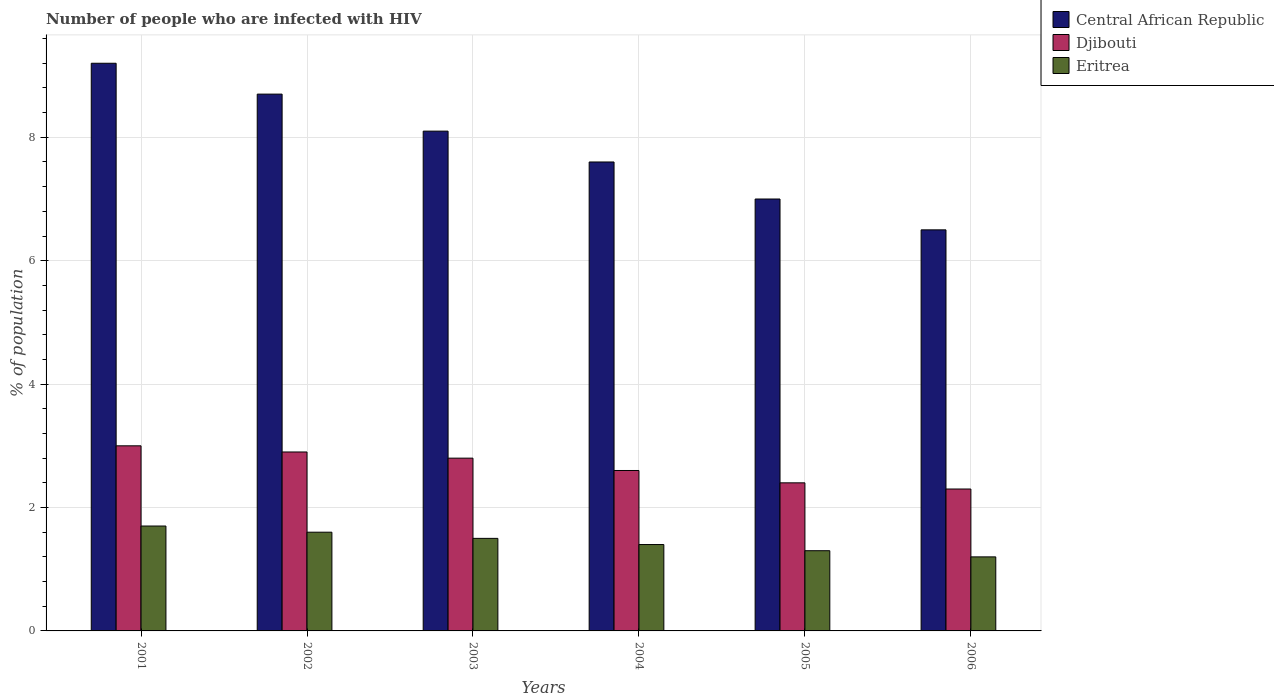How many different coloured bars are there?
Ensure brevity in your answer.  3. How many groups of bars are there?
Your response must be concise. 6. Are the number of bars on each tick of the X-axis equal?
Provide a short and direct response. Yes. How many bars are there on the 6th tick from the right?
Offer a very short reply. 3. What is the label of the 3rd group of bars from the left?
Your response must be concise. 2003. In how many cases, is the number of bars for a given year not equal to the number of legend labels?
Give a very brief answer. 0. In which year was the percentage of HIV infected population in in Central African Republic minimum?
Keep it short and to the point. 2006. What is the total percentage of HIV infected population in in Central African Republic in the graph?
Keep it short and to the point. 47.1. What is the difference between the percentage of HIV infected population in in Eritrea in 2002 and that in 2006?
Offer a very short reply. 0.4. What is the difference between the percentage of HIV infected population in in Central African Republic in 2006 and the percentage of HIV infected population in in Eritrea in 2004?
Your answer should be very brief. 5.1. What is the average percentage of HIV infected population in in Eritrea per year?
Give a very brief answer. 1.45. In the year 2003, what is the difference between the percentage of HIV infected population in in Eritrea and percentage of HIV infected population in in Djibouti?
Give a very brief answer. -1.3. In how many years, is the percentage of HIV infected population in in Eritrea greater than 8.8 %?
Make the answer very short. 0. What is the ratio of the percentage of HIV infected population in in Djibouti in 2001 to that in 2006?
Your answer should be compact. 1.3. What is the difference between the highest and the second highest percentage of HIV infected population in in Djibouti?
Your answer should be compact. 0.1. What is the difference between the highest and the lowest percentage of HIV infected population in in Djibouti?
Offer a terse response. 0.7. Is the sum of the percentage of HIV infected population in in Central African Republic in 2003 and 2005 greater than the maximum percentage of HIV infected population in in Djibouti across all years?
Provide a short and direct response. Yes. What does the 1st bar from the left in 2001 represents?
Provide a succinct answer. Central African Republic. What does the 2nd bar from the right in 2002 represents?
Keep it short and to the point. Djibouti. How many bars are there?
Offer a very short reply. 18. Are all the bars in the graph horizontal?
Make the answer very short. No. What is the difference between two consecutive major ticks on the Y-axis?
Offer a terse response. 2. Does the graph contain any zero values?
Ensure brevity in your answer.  No. How are the legend labels stacked?
Offer a terse response. Vertical. What is the title of the graph?
Give a very brief answer. Number of people who are infected with HIV. What is the label or title of the X-axis?
Offer a very short reply. Years. What is the label or title of the Y-axis?
Provide a succinct answer. % of population. What is the % of population of Djibouti in 2001?
Offer a terse response. 3. What is the % of population in Eritrea in 2001?
Ensure brevity in your answer.  1.7. What is the % of population in Eritrea in 2002?
Offer a terse response. 1.6. What is the % of population of Central African Republic in 2003?
Provide a succinct answer. 8.1. What is the % of population of Eritrea in 2003?
Make the answer very short. 1.5. What is the % of population of Central African Republic in 2004?
Ensure brevity in your answer.  7.6. Across all years, what is the maximum % of population of Central African Republic?
Your response must be concise. 9.2. Across all years, what is the maximum % of population in Eritrea?
Your response must be concise. 1.7. Across all years, what is the minimum % of population of Djibouti?
Your response must be concise. 2.3. Across all years, what is the minimum % of population of Eritrea?
Your response must be concise. 1.2. What is the total % of population of Central African Republic in the graph?
Ensure brevity in your answer.  47.1. What is the total % of population in Eritrea in the graph?
Provide a succinct answer. 8.7. What is the difference between the % of population of Central African Republic in 2001 and that in 2002?
Your answer should be compact. 0.5. What is the difference between the % of population in Djibouti in 2001 and that in 2002?
Your answer should be very brief. 0.1. What is the difference between the % of population in Eritrea in 2001 and that in 2002?
Your answer should be compact. 0.1. What is the difference between the % of population in Central African Republic in 2001 and that in 2003?
Provide a succinct answer. 1.1. What is the difference between the % of population in Djibouti in 2001 and that in 2003?
Make the answer very short. 0.2. What is the difference between the % of population in Djibouti in 2001 and that in 2004?
Provide a short and direct response. 0.4. What is the difference between the % of population of Eritrea in 2001 and that in 2004?
Your answer should be compact. 0.3. What is the difference between the % of population in Djibouti in 2001 and that in 2005?
Provide a short and direct response. 0.6. What is the difference between the % of population in Central African Republic in 2001 and that in 2006?
Provide a short and direct response. 2.7. What is the difference between the % of population of Djibouti in 2001 and that in 2006?
Provide a short and direct response. 0.7. What is the difference between the % of population of Djibouti in 2002 and that in 2003?
Keep it short and to the point. 0.1. What is the difference between the % of population of Central African Republic in 2002 and that in 2004?
Provide a short and direct response. 1.1. What is the difference between the % of population in Djibouti in 2002 and that in 2004?
Keep it short and to the point. 0.3. What is the difference between the % of population in Eritrea in 2002 and that in 2004?
Provide a succinct answer. 0.2. What is the difference between the % of population in Djibouti in 2003 and that in 2004?
Make the answer very short. 0.2. What is the difference between the % of population in Eritrea in 2003 and that in 2004?
Give a very brief answer. 0.1. What is the difference between the % of population in Central African Republic in 2003 and that in 2005?
Offer a very short reply. 1.1. What is the difference between the % of population in Djibouti in 2003 and that in 2005?
Keep it short and to the point. 0.4. What is the difference between the % of population in Central African Republic in 2003 and that in 2006?
Provide a short and direct response. 1.6. What is the difference between the % of population in Eritrea in 2003 and that in 2006?
Keep it short and to the point. 0.3. What is the difference between the % of population of Central African Republic in 2004 and that in 2005?
Give a very brief answer. 0.6. What is the difference between the % of population in Djibouti in 2004 and that in 2005?
Ensure brevity in your answer.  0.2. What is the difference between the % of population in Djibouti in 2004 and that in 2006?
Your answer should be compact. 0.3. What is the difference between the % of population of Central African Republic in 2001 and the % of population of Djibouti in 2002?
Your answer should be very brief. 6.3. What is the difference between the % of population in Central African Republic in 2001 and the % of population in Djibouti in 2003?
Your answer should be very brief. 6.4. What is the difference between the % of population of Central African Republic in 2001 and the % of population of Eritrea in 2003?
Keep it short and to the point. 7.7. What is the difference between the % of population of Djibouti in 2001 and the % of population of Eritrea in 2003?
Give a very brief answer. 1.5. What is the difference between the % of population of Central African Republic in 2001 and the % of population of Djibouti in 2004?
Offer a terse response. 6.6. What is the difference between the % of population in Djibouti in 2001 and the % of population in Eritrea in 2004?
Your answer should be compact. 1.6. What is the difference between the % of population of Djibouti in 2001 and the % of population of Eritrea in 2005?
Offer a terse response. 1.7. What is the difference between the % of population in Central African Republic in 2001 and the % of population in Djibouti in 2006?
Your answer should be compact. 6.9. What is the difference between the % of population in Central African Republic in 2002 and the % of population in Eritrea in 2004?
Your response must be concise. 7.3. What is the difference between the % of population in Djibouti in 2002 and the % of population in Eritrea in 2004?
Offer a very short reply. 1.5. What is the difference between the % of population of Central African Republic in 2002 and the % of population of Djibouti in 2006?
Keep it short and to the point. 6.4. What is the difference between the % of population in Central African Republic in 2002 and the % of population in Eritrea in 2006?
Keep it short and to the point. 7.5. What is the difference between the % of population in Djibouti in 2003 and the % of population in Eritrea in 2004?
Keep it short and to the point. 1.4. What is the difference between the % of population of Djibouti in 2003 and the % of population of Eritrea in 2005?
Provide a short and direct response. 1.5. What is the difference between the % of population in Central African Republic in 2003 and the % of population in Djibouti in 2006?
Your answer should be compact. 5.8. What is the difference between the % of population of Central African Republic in 2004 and the % of population of Djibouti in 2005?
Keep it short and to the point. 5.2. What is the difference between the % of population of Central African Republic in 2004 and the % of population of Eritrea in 2005?
Give a very brief answer. 6.3. What is the difference between the % of population of Djibouti in 2004 and the % of population of Eritrea in 2005?
Offer a terse response. 1.3. What is the difference between the % of population of Central African Republic in 2004 and the % of population of Eritrea in 2006?
Provide a short and direct response. 6.4. What is the difference between the % of population in Djibouti in 2004 and the % of population in Eritrea in 2006?
Offer a terse response. 1.4. What is the difference between the % of population of Central African Republic in 2005 and the % of population of Djibouti in 2006?
Your response must be concise. 4.7. What is the difference between the % of population in Djibouti in 2005 and the % of population in Eritrea in 2006?
Provide a short and direct response. 1.2. What is the average % of population in Central African Republic per year?
Your response must be concise. 7.85. What is the average % of population in Djibouti per year?
Your answer should be compact. 2.67. What is the average % of population in Eritrea per year?
Ensure brevity in your answer.  1.45. In the year 2001, what is the difference between the % of population in Central African Republic and % of population in Eritrea?
Give a very brief answer. 7.5. In the year 2002, what is the difference between the % of population in Central African Republic and % of population in Djibouti?
Make the answer very short. 5.8. In the year 2002, what is the difference between the % of population of Central African Republic and % of population of Eritrea?
Provide a succinct answer. 7.1. In the year 2002, what is the difference between the % of population of Djibouti and % of population of Eritrea?
Make the answer very short. 1.3. In the year 2003, what is the difference between the % of population in Central African Republic and % of population in Djibouti?
Your answer should be compact. 5.3. In the year 2003, what is the difference between the % of population in Central African Republic and % of population in Eritrea?
Provide a succinct answer. 6.6. In the year 2004, what is the difference between the % of population in Central African Republic and % of population in Djibouti?
Offer a terse response. 5. In the year 2005, what is the difference between the % of population of Djibouti and % of population of Eritrea?
Offer a very short reply. 1.1. In the year 2006, what is the difference between the % of population in Central African Republic and % of population in Djibouti?
Make the answer very short. 4.2. What is the ratio of the % of population in Central African Republic in 2001 to that in 2002?
Offer a terse response. 1.06. What is the ratio of the % of population of Djibouti in 2001 to that in 2002?
Offer a terse response. 1.03. What is the ratio of the % of population in Central African Republic in 2001 to that in 2003?
Provide a short and direct response. 1.14. What is the ratio of the % of population in Djibouti in 2001 to that in 2003?
Provide a succinct answer. 1.07. What is the ratio of the % of population of Eritrea in 2001 to that in 2003?
Provide a succinct answer. 1.13. What is the ratio of the % of population of Central African Republic in 2001 to that in 2004?
Keep it short and to the point. 1.21. What is the ratio of the % of population in Djibouti in 2001 to that in 2004?
Give a very brief answer. 1.15. What is the ratio of the % of population in Eritrea in 2001 to that in 2004?
Give a very brief answer. 1.21. What is the ratio of the % of population of Central African Republic in 2001 to that in 2005?
Keep it short and to the point. 1.31. What is the ratio of the % of population in Djibouti in 2001 to that in 2005?
Your response must be concise. 1.25. What is the ratio of the % of population in Eritrea in 2001 to that in 2005?
Provide a short and direct response. 1.31. What is the ratio of the % of population in Central African Republic in 2001 to that in 2006?
Keep it short and to the point. 1.42. What is the ratio of the % of population of Djibouti in 2001 to that in 2006?
Provide a short and direct response. 1.3. What is the ratio of the % of population of Eritrea in 2001 to that in 2006?
Provide a succinct answer. 1.42. What is the ratio of the % of population of Central African Republic in 2002 to that in 2003?
Provide a short and direct response. 1.07. What is the ratio of the % of population of Djibouti in 2002 to that in 2003?
Provide a succinct answer. 1.04. What is the ratio of the % of population in Eritrea in 2002 to that in 2003?
Your answer should be very brief. 1.07. What is the ratio of the % of population of Central African Republic in 2002 to that in 2004?
Offer a very short reply. 1.14. What is the ratio of the % of population of Djibouti in 2002 to that in 2004?
Ensure brevity in your answer.  1.12. What is the ratio of the % of population of Eritrea in 2002 to that in 2004?
Provide a succinct answer. 1.14. What is the ratio of the % of population of Central African Republic in 2002 to that in 2005?
Offer a terse response. 1.24. What is the ratio of the % of population of Djibouti in 2002 to that in 2005?
Ensure brevity in your answer.  1.21. What is the ratio of the % of population of Eritrea in 2002 to that in 2005?
Give a very brief answer. 1.23. What is the ratio of the % of population in Central African Republic in 2002 to that in 2006?
Provide a short and direct response. 1.34. What is the ratio of the % of population in Djibouti in 2002 to that in 2006?
Offer a terse response. 1.26. What is the ratio of the % of population in Central African Republic in 2003 to that in 2004?
Offer a very short reply. 1.07. What is the ratio of the % of population of Eritrea in 2003 to that in 2004?
Give a very brief answer. 1.07. What is the ratio of the % of population of Central African Republic in 2003 to that in 2005?
Keep it short and to the point. 1.16. What is the ratio of the % of population in Eritrea in 2003 to that in 2005?
Your answer should be very brief. 1.15. What is the ratio of the % of population in Central African Republic in 2003 to that in 2006?
Keep it short and to the point. 1.25. What is the ratio of the % of population in Djibouti in 2003 to that in 2006?
Your response must be concise. 1.22. What is the ratio of the % of population in Eritrea in 2003 to that in 2006?
Provide a succinct answer. 1.25. What is the ratio of the % of population in Central African Republic in 2004 to that in 2005?
Your answer should be compact. 1.09. What is the ratio of the % of population in Djibouti in 2004 to that in 2005?
Your answer should be very brief. 1.08. What is the ratio of the % of population in Eritrea in 2004 to that in 2005?
Your answer should be very brief. 1.08. What is the ratio of the % of population of Central African Republic in 2004 to that in 2006?
Provide a short and direct response. 1.17. What is the ratio of the % of population of Djibouti in 2004 to that in 2006?
Your answer should be very brief. 1.13. What is the ratio of the % of population in Eritrea in 2004 to that in 2006?
Offer a very short reply. 1.17. What is the ratio of the % of population of Djibouti in 2005 to that in 2006?
Provide a succinct answer. 1.04. What is the ratio of the % of population in Eritrea in 2005 to that in 2006?
Your answer should be very brief. 1.08. What is the difference between the highest and the second highest % of population in Djibouti?
Ensure brevity in your answer.  0.1. What is the difference between the highest and the second highest % of population of Eritrea?
Your answer should be compact. 0.1. What is the difference between the highest and the lowest % of population in Central African Republic?
Provide a succinct answer. 2.7. What is the difference between the highest and the lowest % of population in Djibouti?
Give a very brief answer. 0.7. What is the difference between the highest and the lowest % of population in Eritrea?
Your answer should be very brief. 0.5. 